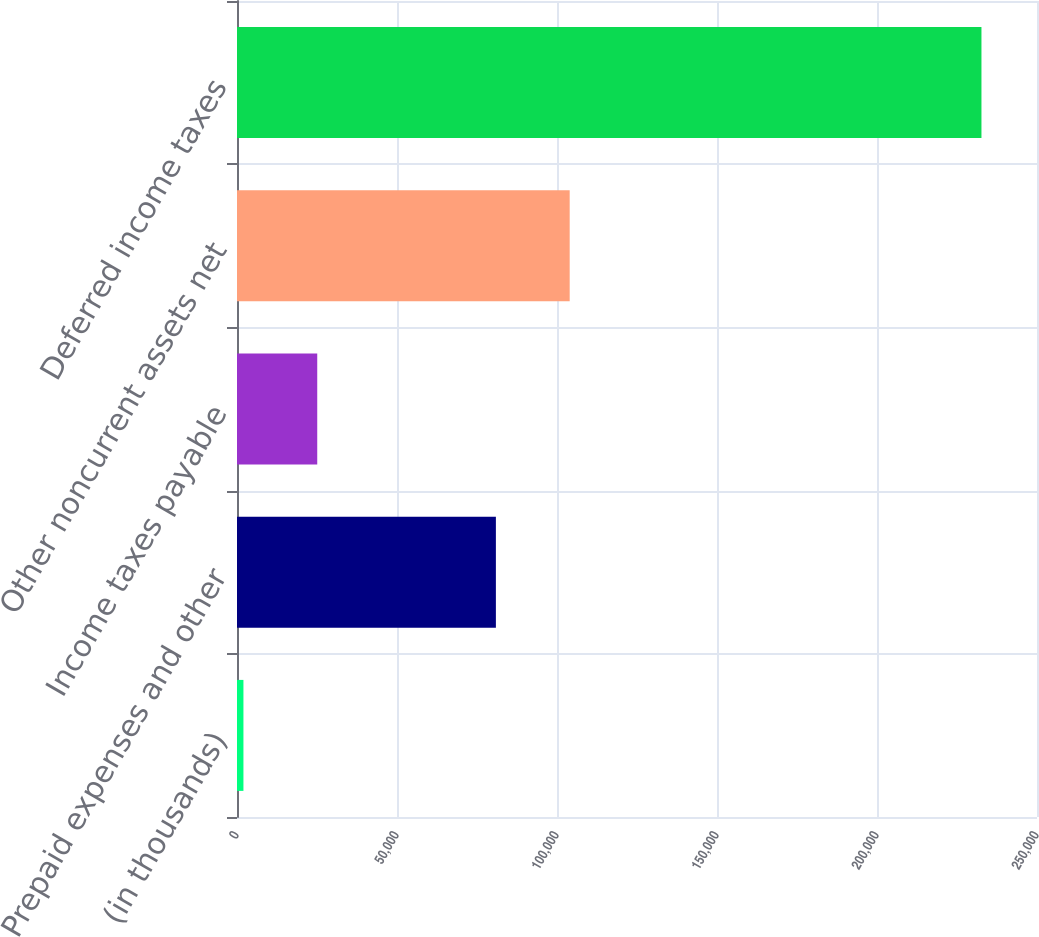<chart> <loc_0><loc_0><loc_500><loc_500><bar_chart><fcel>(in thousands)<fcel>Prepaid expenses and other<fcel>Income taxes payable<fcel>Other noncurrent assets net<fcel>Deferred income taxes<nl><fcel>2012<fcel>80903<fcel>25074.9<fcel>103966<fcel>232641<nl></chart> 